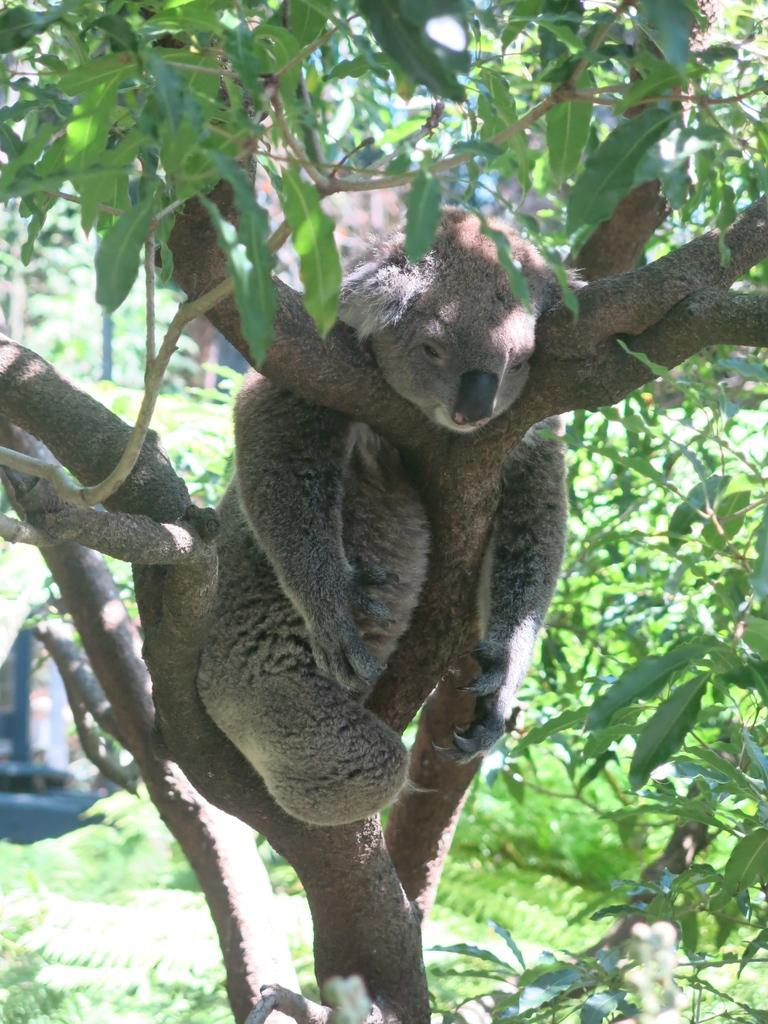What type of living organism can be seen in the image? There is an animal in the image. Where is the animal located in the image? The animal is on the branch of a tree. What part of the tree is visible in the image? The tree branch is in the foreground of the image. What is the view of the winter landscape from the animal's perspective in the image? There is no information about the season or landscape in the image, and the animal's perspective cannot be determined. 